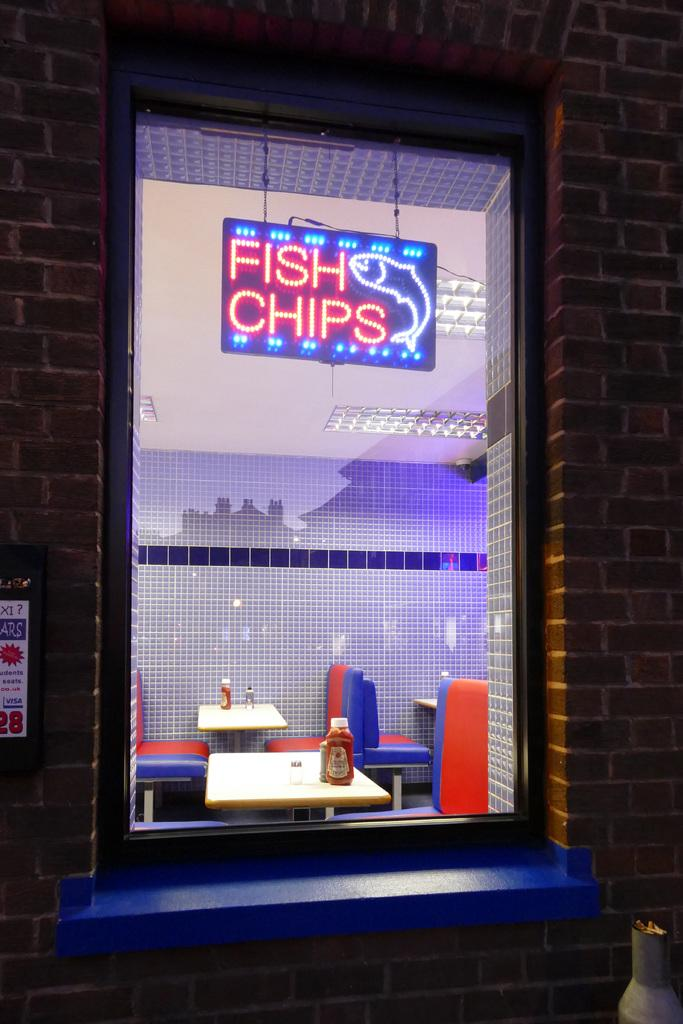What can be seen in the image that provides a view of the outdoors? There is a window in the image that provides a view of the outdoors. What type of furniture is visible in the background of the image? There are tables and chairs in the background of the image. What colors are the chairs in the image? The chairs have blue and red colors. What type of stem can be seen growing from the chairs in the image? There are no stems growing from the chairs in the image; they are chairs with blue and red colors. 